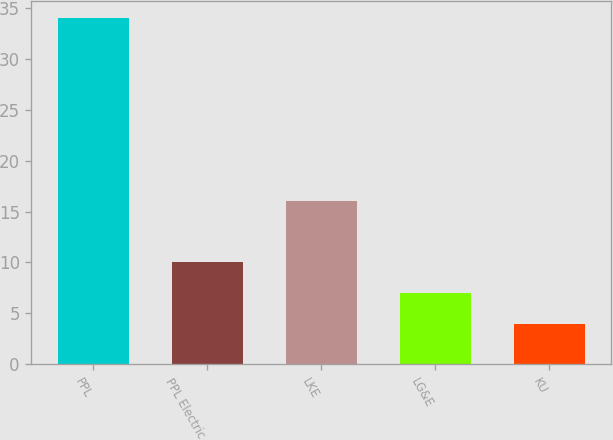<chart> <loc_0><loc_0><loc_500><loc_500><bar_chart><fcel>PPL<fcel>PPL Electric<fcel>LKE<fcel>LG&E<fcel>KU<nl><fcel>34<fcel>10<fcel>16<fcel>7<fcel>4<nl></chart> 